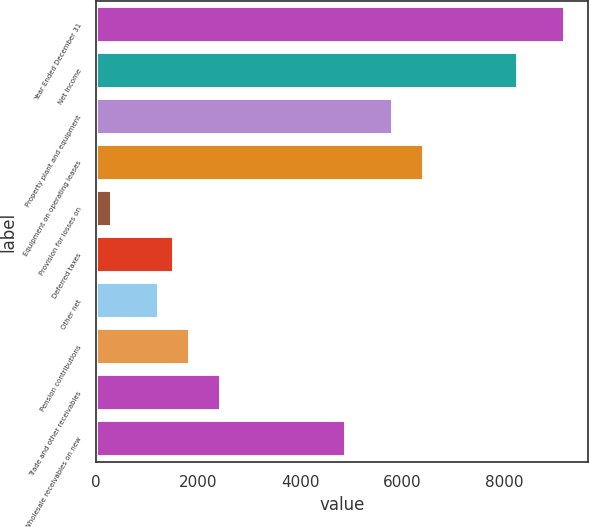Convert chart. <chart><loc_0><loc_0><loc_500><loc_500><bar_chart><fcel>Year Ended December 31<fcel>Net Income<fcel>Property plant and equipment<fcel>Equipment on operating leases<fcel>Provision for losses on<fcel>Deferred taxes<fcel>Other net<fcel>Pension contributions<fcel>Trade and other receivables<fcel>Wholesale receivables on new<nl><fcel>9180.3<fcel>8262.93<fcel>5816.61<fcel>6428.19<fcel>312.39<fcel>1535.55<fcel>1229.76<fcel>1841.34<fcel>2452.92<fcel>4899.24<nl></chart> 